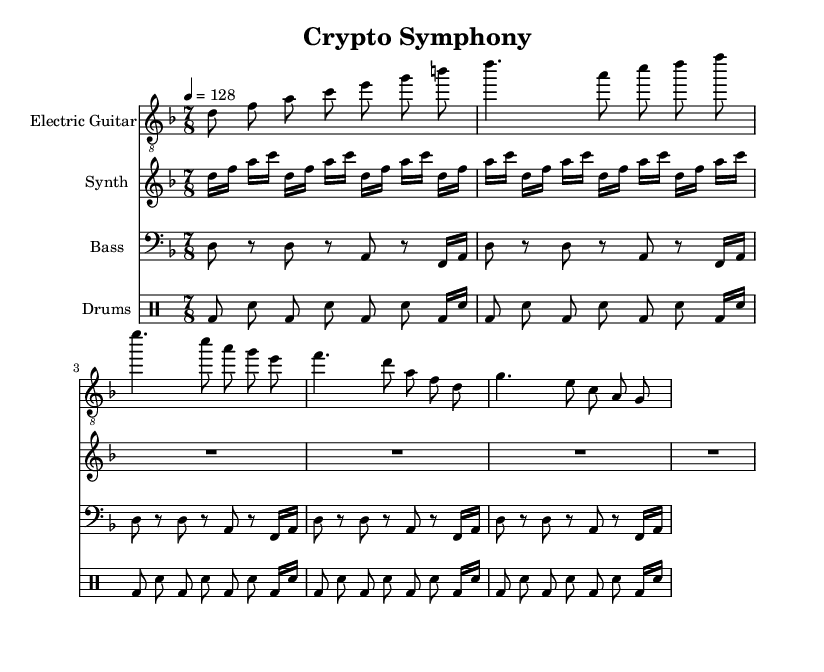What is the key signature of this music? The key signature is D minor, indicated by the presence of one flat (B flat).
Answer: D minor What is the time signature? The time signature is seven eighths, which is shown at the beginning of the score as "7/8".
Answer: 7/8 What is the tempo marking in this piece? The tempo marking indicates a speed of 128 beats per minute, specified as "4 = 128".
Answer: 128 Which instrument plays the melody in the introduction? The electric guitar plays the melody in the introduction with a series of ascending pitches: d, f, a, c, e, g, b.
Answer: Electric Guitar How many measures are present in the verse section for each instrument? Each instrument has four measures in the verse section, breaking down the rhythm and melodic line.
Answer: Four What rhythmic pattern is primarily used in the drum part? The drum part primarily alternates between bass drum and snare, maintaining a consistent energetic rhythm with bass drums on the downbeats.
Answer: Alternating bass and snare What characterizes the synth part throughout the piece? The synth part consists solely of rests in the verse and chorus, creating a unique contrast against the other instruments.
Answer: Rests 